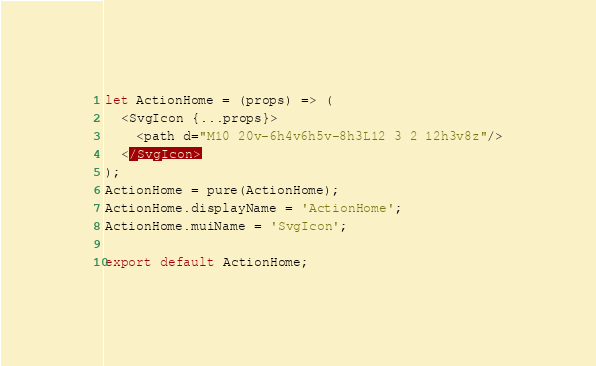Convert code to text. <code><loc_0><loc_0><loc_500><loc_500><_JavaScript_>let ActionHome = (props) => (
  <SvgIcon {...props}>
    <path d="M10 20v-6h4v6h5v-8h3L12 3 2 12h3v8z"/>
  </SvgIcon>
);
ActionHome = pure(ActionHome);
ActionHome.displayName = 'ActionHome';
ActionHome.muiName = 'SvgIcon';

export default ActionHome;
</code> 